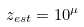Convert formula to latex. <formula><loc_0><loc_0><loc_500><loc_500>z _ { e s t } = 1 0 ^ { \mu }</formula> 